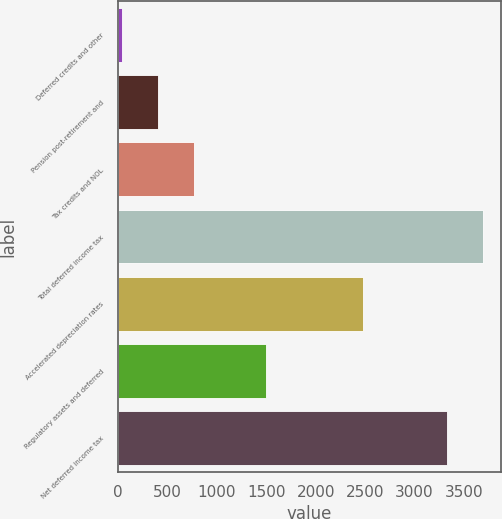Convert chart. <chart><loc_0><loc_0><loc_500><loc_500><bar_chart><fcel>Deferred credits and other<fcel>Pension post-retirement and<fcel>Tax credits and NOL<fcel>Total deferred income tax<fcel>Accelerated depreciation rates<fcel>Regulatory assets and deferred<fcel>Net deferred income tax<nl><fcel>40<fcel>404.4<fcel>768.8<fcel>3687.4<fcel>2479<fcel>1497.6<fcel>3323<nl></chart> 